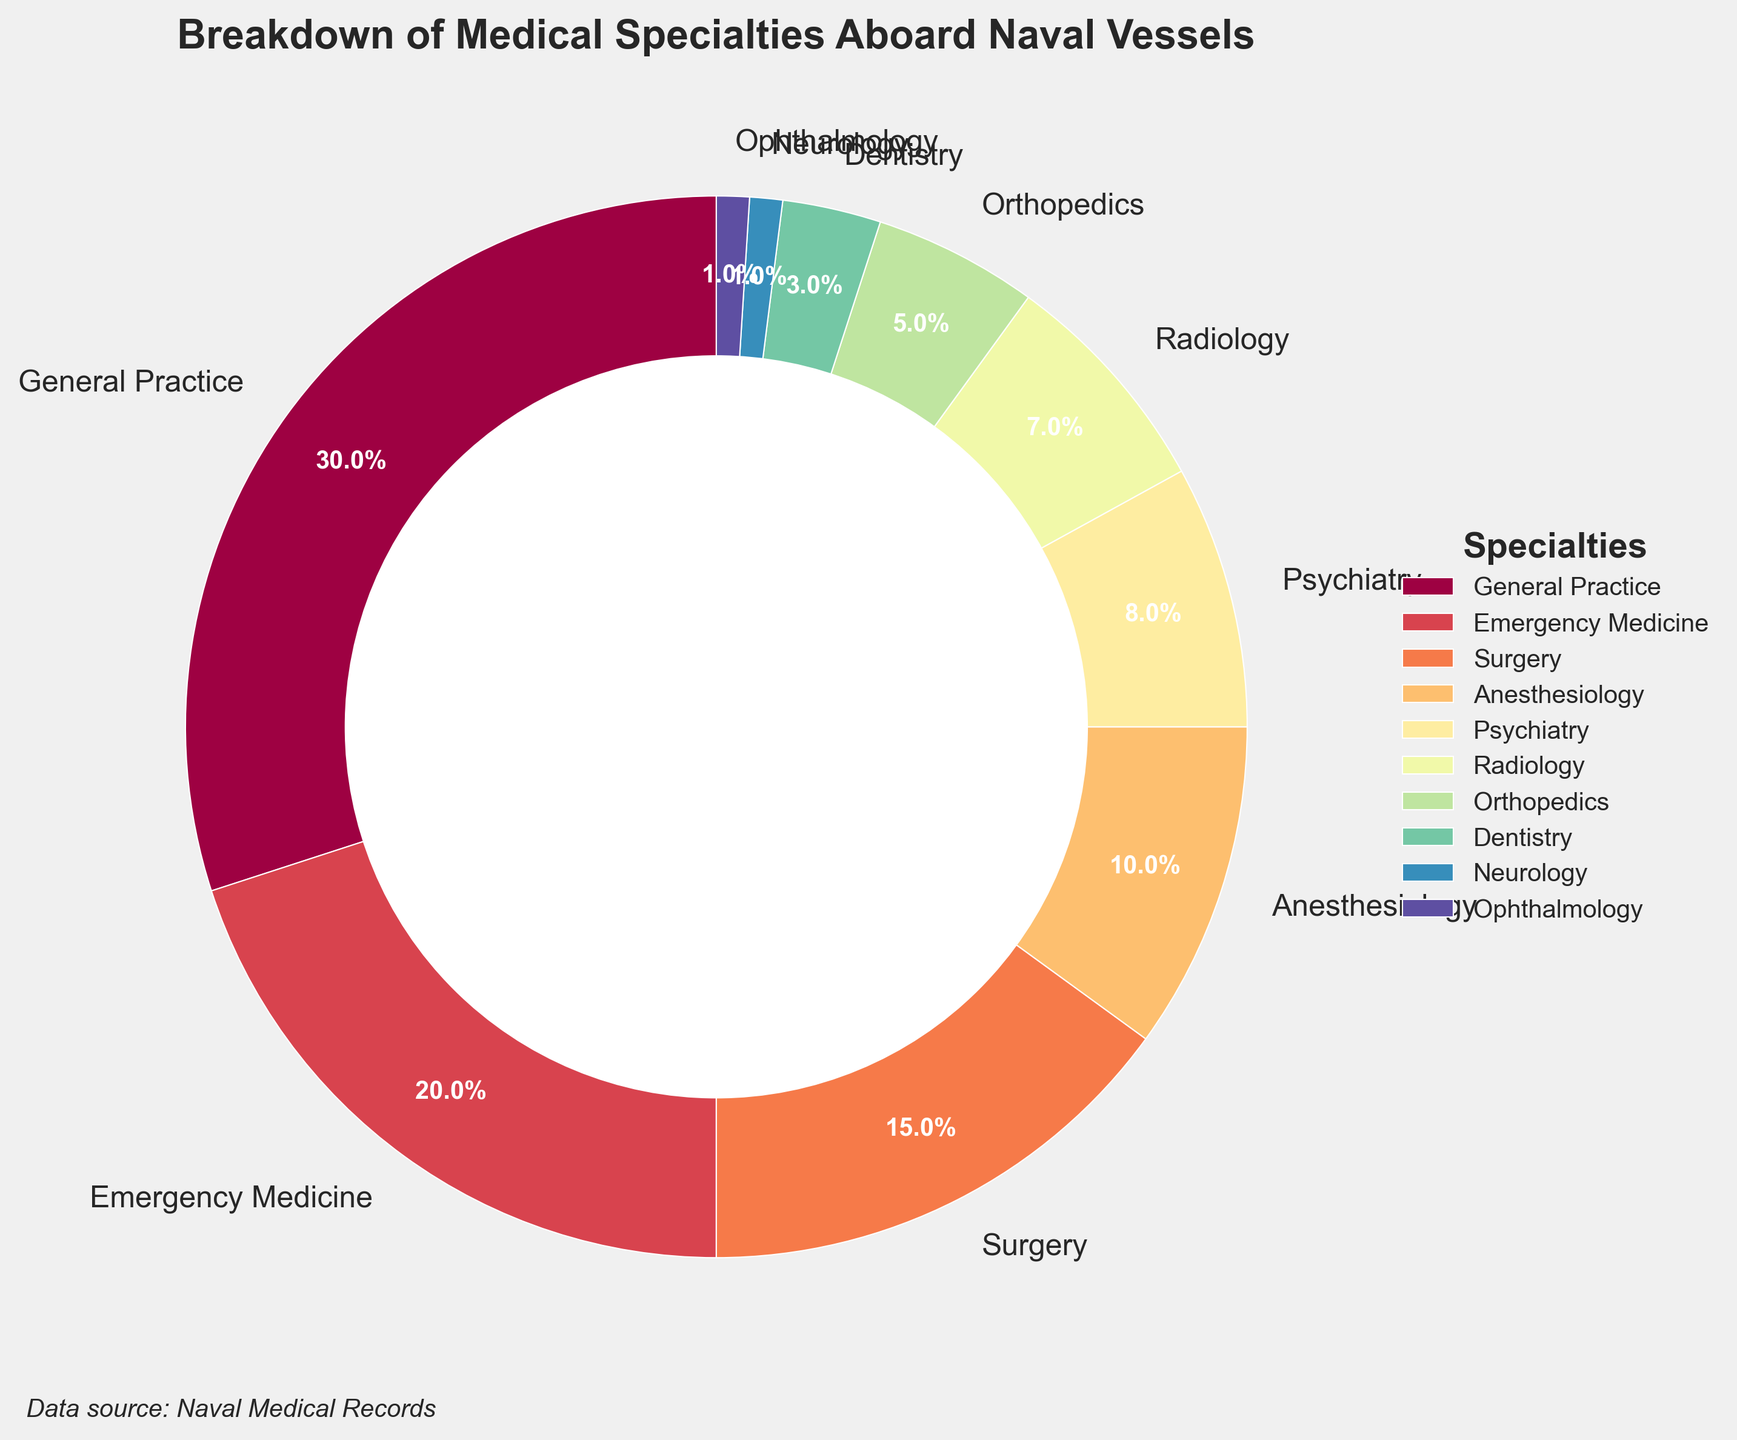What is the percentage difference between General Practice and Surgery? General Practice is at 30% and Surgery is at 15%. To find the difference, subtract 15 from 30.
Answer: 15% Compare the total percentage of Psychiatry and Radiology to Anesthesiology. Which one has a higher percentage, and by how much? Psychiatry is 8% and Radiology is 7%. Together, they make 15% (8% + 7%). Anesthesiology is 10%. To find which one is higher and by how much, subtract 10% from 15%.
Answer: Psychiatry and Radiology by 5% Which specialty occupies the smallest slice of the pie chart, and what is its percentage? From the chart, we see that both Neurology and Ophthalmology occupy equally small slices. Each has a percentage of 1%.
Answer: Neurology and Ophthalmology, 1% each How many specialties have a percentage greater than 5%? By looking at the chart, General Practice (30%), Emergency Medicine (20%), Surgery (15%), Anesthesiology (10%), and Psychiatry (8%) all have percentages greater than 5%. Count these specialties.
Answer: 5 specialties Compare the percentage of Dentistry to Orthopedics. Which one is larger, and by how much? Dentistry is at 3% and Orthopedics is at 5%. To see which is larger and by how much, subtract 3% from 5%.
Answer: Orthopedics is larger by 2% What is the combined percentage of Emergency Medicine, Surgery, and Anesthesiology? Emergency Medicine is at 20%, Surgery at 15%, and Anesthesiology at 10%. Adding them together gives 20% + 15% + 10%.
Answer: 45% What percentage accounts for the smallest half of the chart's slices? To find the smallest half, start by listing all the percentages and add up the smaller values until reaching near 50%. Adding the smallest ones first: Neurology (1%), Ophthalmology (1%), Dentistry (3%), Orthopedics (5%), Radiology (7%), and Psychiatry (8%), their sum is 25%. Adding Anesthesiology’s 10% and Surgery’s 15% gives us a total of 50%.
Answer: 50% Out of the specialties listed, which four collectively have the largest percentage? To identify the top four percentages: General Practice (30%), Emergency Medicine (20%), Surgery (15%), and Anesthesiology (10%). Their sum gives 30% + 20% + 15% + 10%.
Answer: General Practice, Emergency Medicine, Surgery, Anesthesiology What is the percentage if you combine the "General Practice" with the lower three specialties? General Practice is 30%. The lower three specialties are Neurology (1%), Ophthalmology (1%), and Dentistry (3%). Adding them gives 30% + 1% + 1% + 3%.
Answer: 35% 